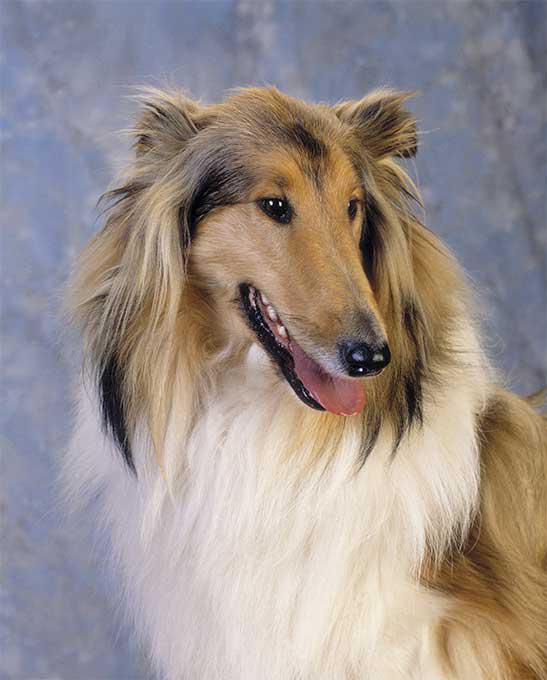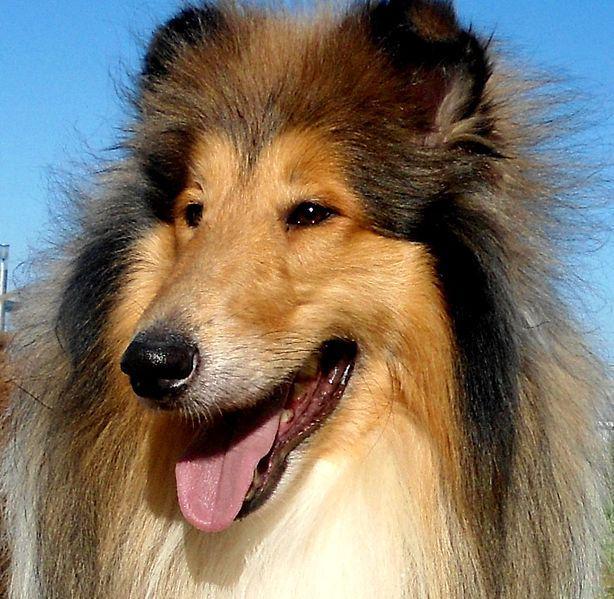The first image is the image on the left, the second image is the image on the right. Analyze the images presented: Is the assertion "in at least one image there is a dog standing in the grass" valid? Answer yes or no. No. The first image is the image on the left, the second image is the image on the right. Examine the images to the left and right. Is the description "The right image shows a collie posed on green grass." accurate? Answer yes or no. No. The first image is the image on the left, the second image is the image on the right. For the images shown, is this caption "One fluffy dog is standing in the grass near flowers." true? Answer yes or no. No. 